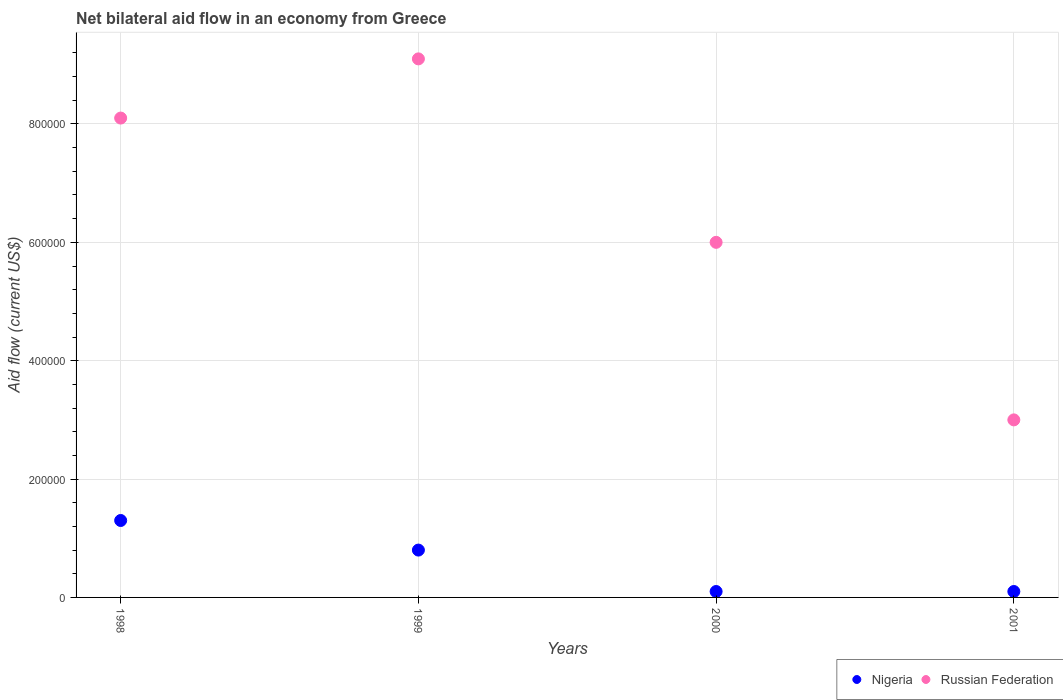Across all years, what is the maximum net bilateral aid flow in Russian Federation?
Give a very brief answer. 9.10e+05. Across all years, what is the minimum net bilateral aid flow in Nigeria?
Provide a short and direct response. 10000. In which year was the net bilateral aid flow in Nigeria minimum?
Provide a short and direct response. 2000. What is the total net bilateral aid flow in Russian Federation in the graph?
Your response must be concise. 2.62e+06. What is the average net bilateral aid flow in Russian Federation per year?
Keep it short and to the point. 6.55e+05. In the year 2000, what is the difference between the net bilateral aid flow in Russian Federation and net bilateral aid flow in Nigeria?
Your response must be concise. 5.90e+05. In how many years, is the net bilateral aid flow in Russian Federation greater than 280000 US$?
Provide a succinct answer. 4. What is the difference between the highest and the second highest net bilateral aid flow in Nigeria?
Your response must be concise. 5.00e+04. Is the sum of the net bilateral aid flow in Nigeria in 1999 and 2000 greater than the maximum net bilateral aid flow in Russian Federation across all years?
Your answer should be very brief. No. Is the net bilateral aid flow in Russian Federation strictly less than the net bilateral aid flow in Nigeria over the years?
Provide a short and direct response. No. How many dotlines are there?
Ensure brevity in your answer.  2. What is the difference between two consecutive major ticks on the Y-axis?
Your answer should be very brief. 2.00e+05. Are the values on the major ticks of Y-axis written in scientific E-notation?
Provide a short and direct response. No. Does the graph contain grids?
Your response must be concise. Yes. What is the title of the graph?
Keep it short and to the point. Net bilateral aid flow in an economy from Greece. Does "Ireland" appear as one of the legend labels in the graph?
Keep it short and to the point. No. What is the label or title of the Y-axis?
Make the answer very short. Aid flow (current US$). What is the Aid flow (current US$) in Russian Federation in 1998?
Your answer should be compact. 8.10e+05. What is the Aid flow (current US$) of Nigeria in 1999?
Your answer should be compact. 8.00e+04. What is the Aid flow (current US$) of Russian Federation in 1999?
Offer a very short reply. 9.10e+05. What is the Aid flow (current US$) of Nigeria in 2000?
Your answer should be very brief. 10000. Across all years, what is the maximum Aid flow (current US$) in Russian Federation?
Your response must be concise. 9.10e+05. What is the total Aid flow (current US$) in Nigeria in the graph?
Give a very brief answer. 2.30e+05. What is the total Aid flow (current US$) in Russian Federation in the graph?
Give a very brief answer. 2.62e+06. What is the difference between the Aid flow (current US$) in Russian Federation in 1998 and that in 1999?
Offer a terse response. -1.00e+05. What is the difference between the Aid flow (current US$) of Nigeria in 1998 and that in 2000?
Ensure brevity in your answer.  1.20e+05. What is the difference between the Aid flow (current US$) in Russian Federation in 1998 and that in 2001?
Make the answer very short. 5.10e+05. What is the difference between the Aid flow (current US$) in Nigeria in 1999 and that in 2000?
Provide a short and direct response. 7.00e+04. What is the difference between the Aid flow (current US$) of Russian Federation in 1999 and that in 2000?
Your answer should be compact. 3.10e+05. What is the difference between the Aid flow (current US$) of Nigeria in 1999 and that in 2001?
Ensure brevity in your answer.  7.00e+04. What is the difference between the Aid flow (current US$) of Nigeria in 2000 and that in 2001?
Your response must be concise. 0. What is the difference between the Aid flow (current US$) in Russian Federation in 2000 and that in 2001?
Your response must be concise. 3.00e+05. What is the difference between the Aid flow (current US$) of Nigeria in 1998 and the Aid flow (current US$) of Russian Federation in 1999?
Offer a terse response. -7.80e+05. What is the difference between the Aid flow (current US$) of Nigeria in 1998 and the Aid flow (current US$) of Russian Federation in 2000?
Offer a terse response. -4.70e+05. What is the difference between the Aid flow (current US$) of Nigeria in 1999 and the Aid flow (current US$) of Russian Federation in 2000?
Your answer should be very brief. -5.20e+05. What is the difference between the Aid flow (current US$) of Nigeria in 1999 and the Aid flow (current US$) of Russian Federation in 2001?
Offer a terse response. -2.20e+05. What is the average Aid flow (current US$) of Nigeria per year?
Your answer should be very brief. 5.75e+04. What is the average Aid flow (current US$) of Russian Federation per year?
Keep it short and to the point. 6.55e+05. In the year 1998, what is the difference between the Aid flow (current US$) in Nigeria and Aid flow (current US$) in Russian Federation?
Your answer should be very brief. -6.80e+05. In the year 1999, what is the difference between the Aid flow (current US$) in Nigeria and Aid flow (current US$) in Russian Federation?
Your response must be concise. -8.30e+05. In the year 2000, what is the difference between the Aid flow (current US$) in Nigeria and Aid flow (current US$) in Russian Federation?
Provide a short and direct response. -5.90e+05. In the year 2001, what is the difference between the Aid flow (current US$) in Nigeria and Aid flow (current US$) in Russian Federation?
Offer a terse response. -2.90e+05. What is the ratio of the Aid flow (current US$) of Nigeria in 1998 to that in 1999?
Provide a succinct answer. 1.62. What is the ratio of the Aid flow (current US$) of Russian Federation in 1998 to that in 1999?
Ensure brevity in your answer.  0.89. What is the ratio of the Aid flow (current US$) of Russian Federation in 1998 to that in 2000?
Ensure brevity in your answer.  1.35. What is the ratio of the Aid flow (current US$) of Nigeria in 1998 to that in 2001?
Offer a very short reply. 13. What is the ratio of the Aid flow (current US$) in Russian Federation in 1999 to that in 2000?
Ensure brevity in your answer.  1.52. What is the ratio of the Aid flow (current US$) of Nigeria in 1999 to that in 2001?
Keep it short and to the point. 8. What is the ratio of the Aid flow (current US$) of Russian Federation in 1999 to that in 2001?
Your response must be concise. 3.03. What is the ratio of the Aid flow (current US$) in Nigeria in 2000 to that in 2001?
Offer a very short reply. 1. What is the ratio of the Aid flow (current US$) in Russian Federation in 2000 to that in 2001?
Make the answer very short. 2. What is the difference between the highest and the second highest Aid flow (current US$) of Russian Federation?
Give a very brief answer. 1.00e+05. What is the difference between the highest and the lowest Aid flow (current US$) in Nigeria?
Offer a very short reply. 1.20e+05. 